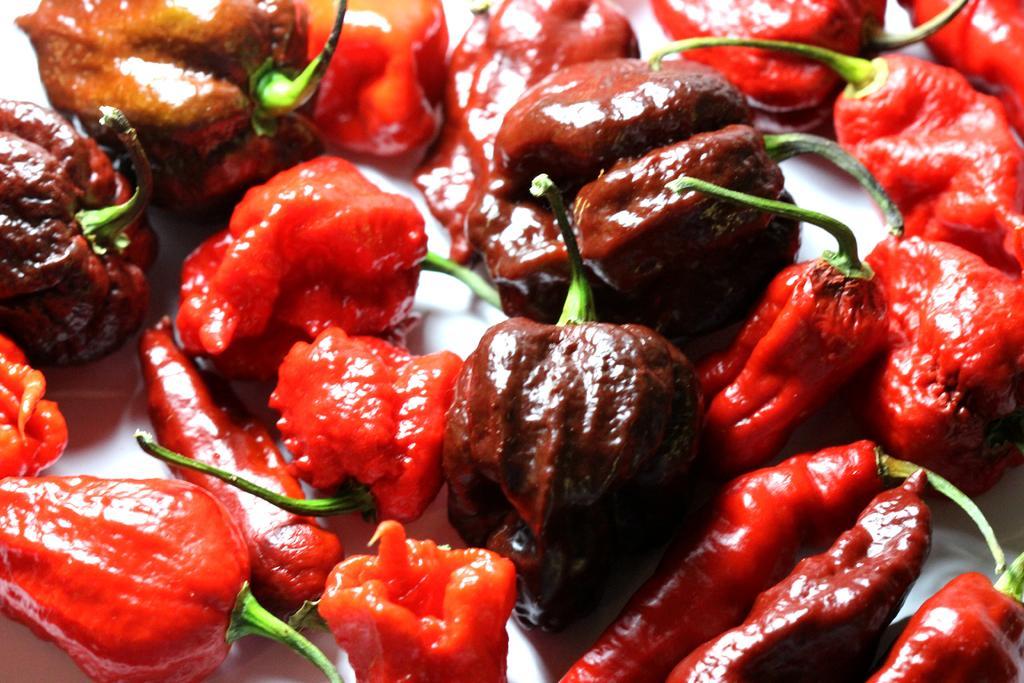Could you give a brief overview of what you see in this image? Here in this picture we can see number of pimentos present over a place. 